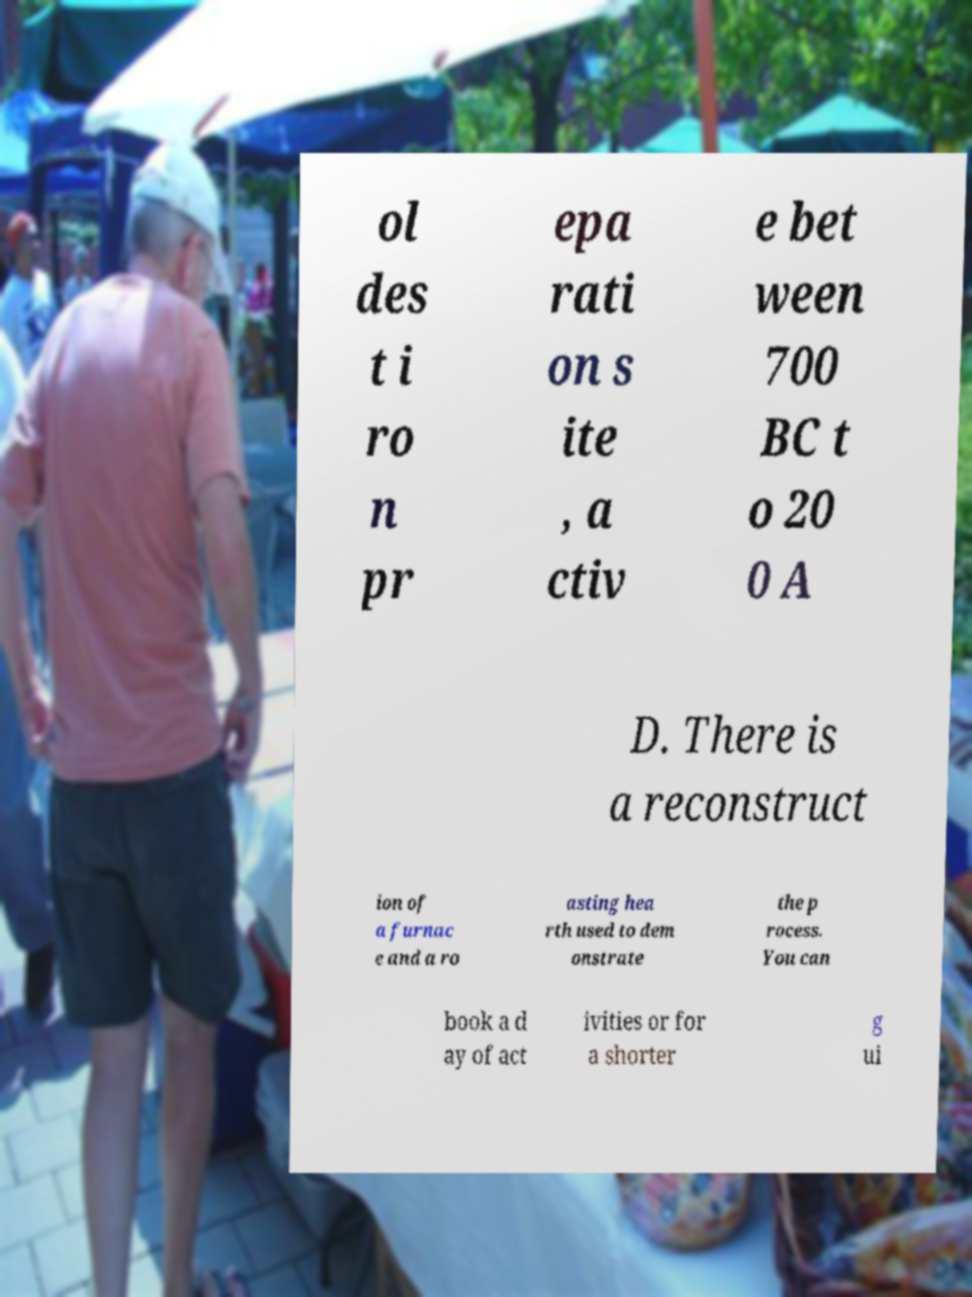Please identify and transcribe the text found in this image. ol des t i ro n pr epa rati on s ite , a ctiv e bet ween 700 BC t o 20 0 A D. There is a reconstruct ion of a furnac e and a ro asting hea rth used to dem onstrate the p rocess. You can book a d ay of act ivities or for a shorter g ui 